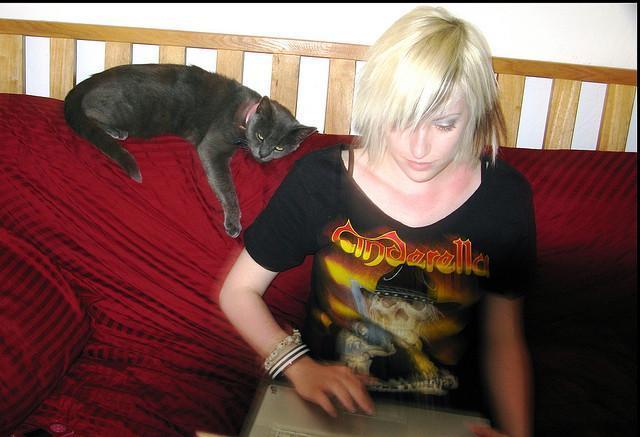How many people are visible?
Give a very brief answer. 1. How many couches are in the photo?
Give a very brief answer. 1. How many train cars have yellow on them?
Give a very brief answer. 0. 